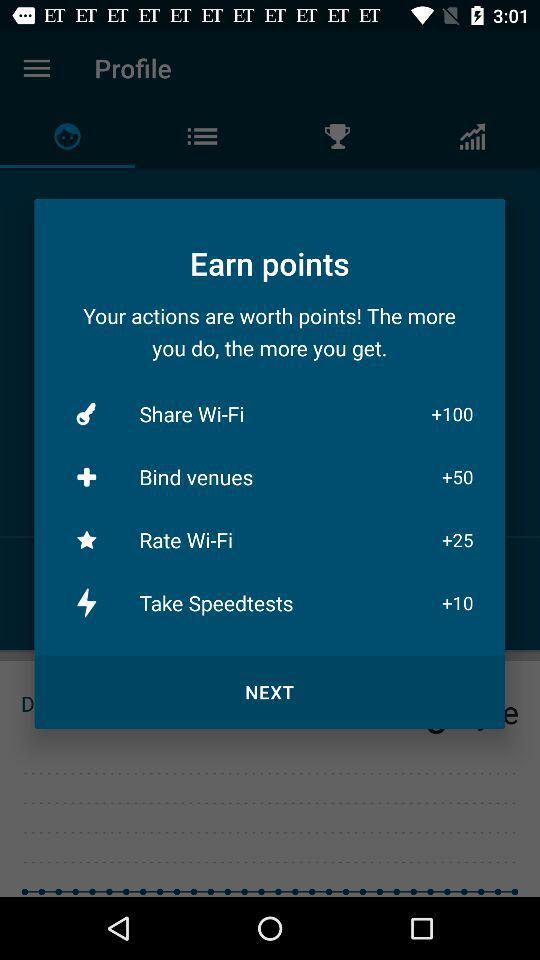How many points can I earn by sharing Wi-Fi? You can earn 100 points by sharing Wi-Fi. 